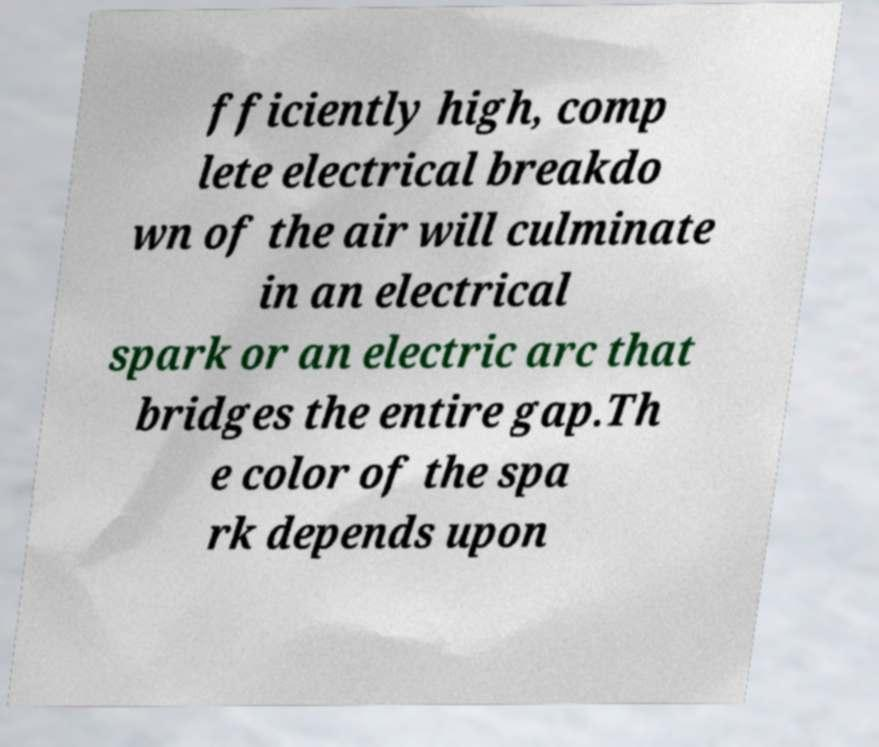Can you read and provide the text displayed in the image?This photo seems to have some interesting text. Can you extract and type it out for me? fficiently high, comp lete electrical breakdo wn of the air will culminate in an electrical spark or an electric arc that bridges the entire gap.Th e color of the spa rk depends upon 